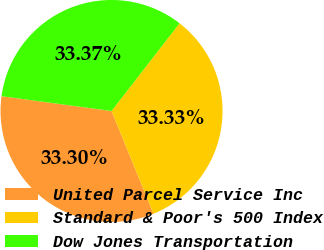Convert chart. <chart><loc_0><loc_0><loc_500><loc_500><pie_chart><fcel>United Parcel Service Inc<fcel>Standard & Poor's 500 Index<fcel>Dow Jones Transportation<nl><fcel>33.3%<fcel>33.33%<fcel>33.37%<nl></chart> 